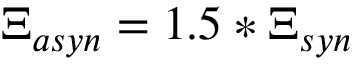Convert formula to latex. <formula><loc_0><loc_0><loc_500><loc_500>\Xi _ { a s y n } = 1 . 5 * \Xi _ { s y n }</formula> 